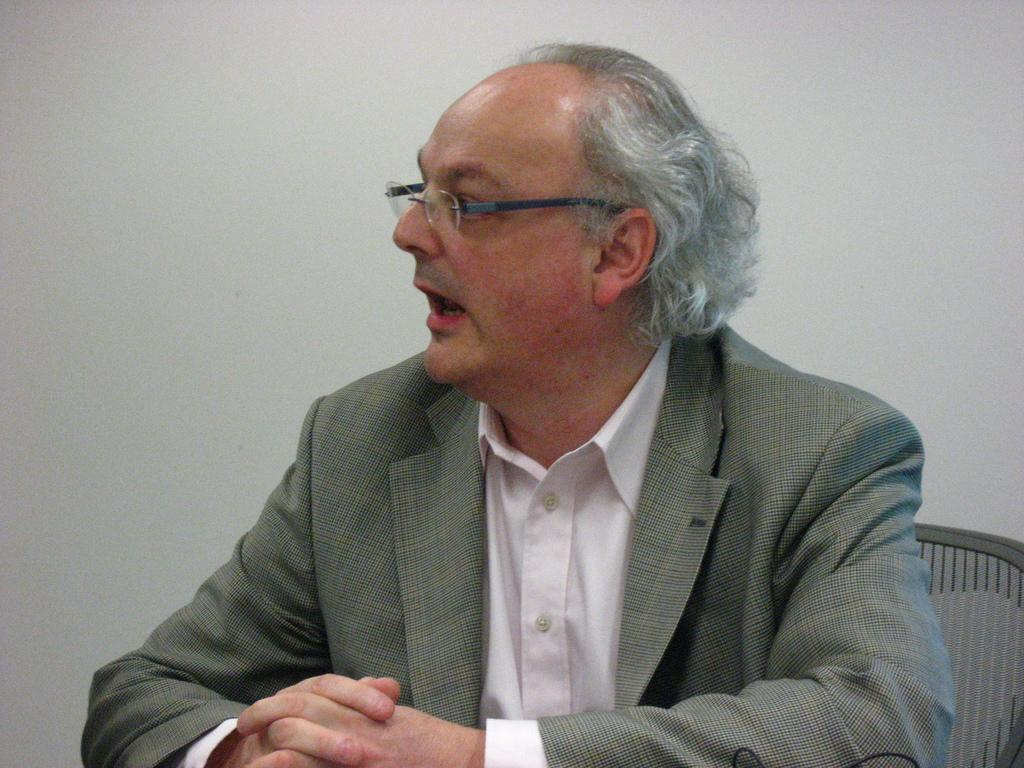Who is present in the image? There is a man in the picture. What is the man doing in the image? The man is sitting and talking. What can be seen in the background of the image? There is a wall in the background of the picture. What type of clouds can be seen in the image? There are no clouds visible in the image; it features a man sitting and talking with a wall in the background. 